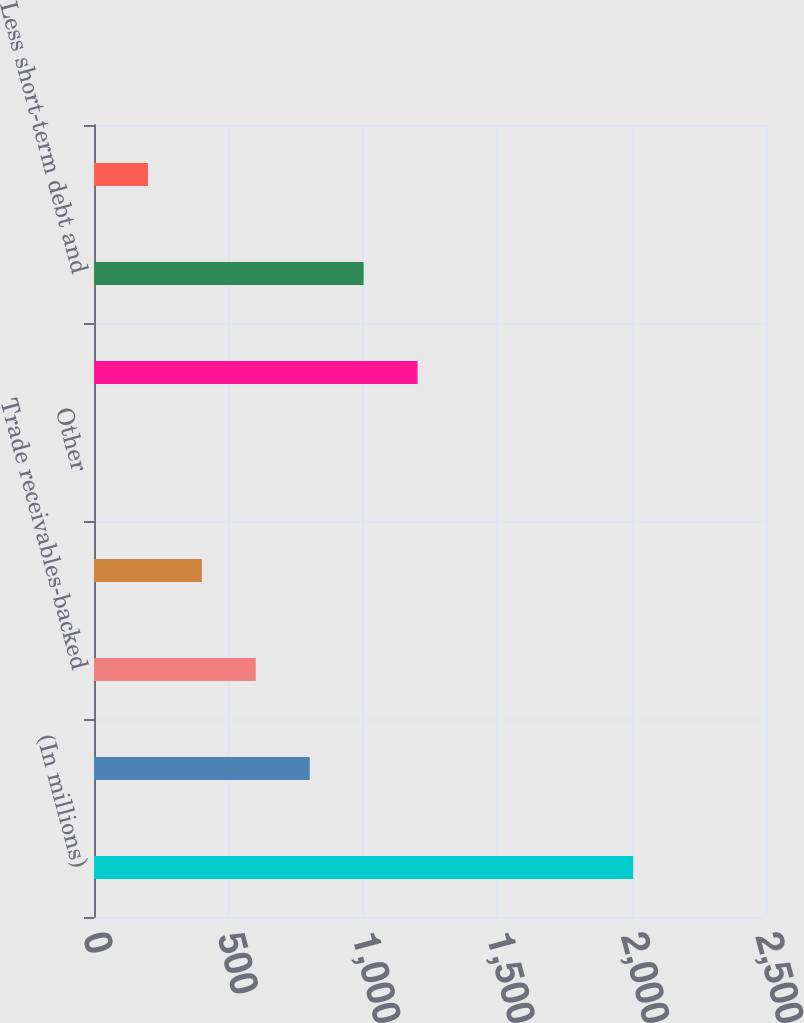Convert chart. <chart><loc_0><loc_0><loc_500><loc_500><bar_chart><fcel>(In millions)<fcel>Debentures 69 due July 2028<fcel>Trade receivables-backed<fcel>Long-term revolving credit<fcel>Other<fcel>Total debt<fcel>Less short-term debt and<fcel>Less unamortized discounts<nl><fcel>2006<fcel>802.46<fcel>601.87<fcel>401.28<fcel>0.1<fcel>1203.64<fcel>1003.05<fcel>200.69<nl></chart> 